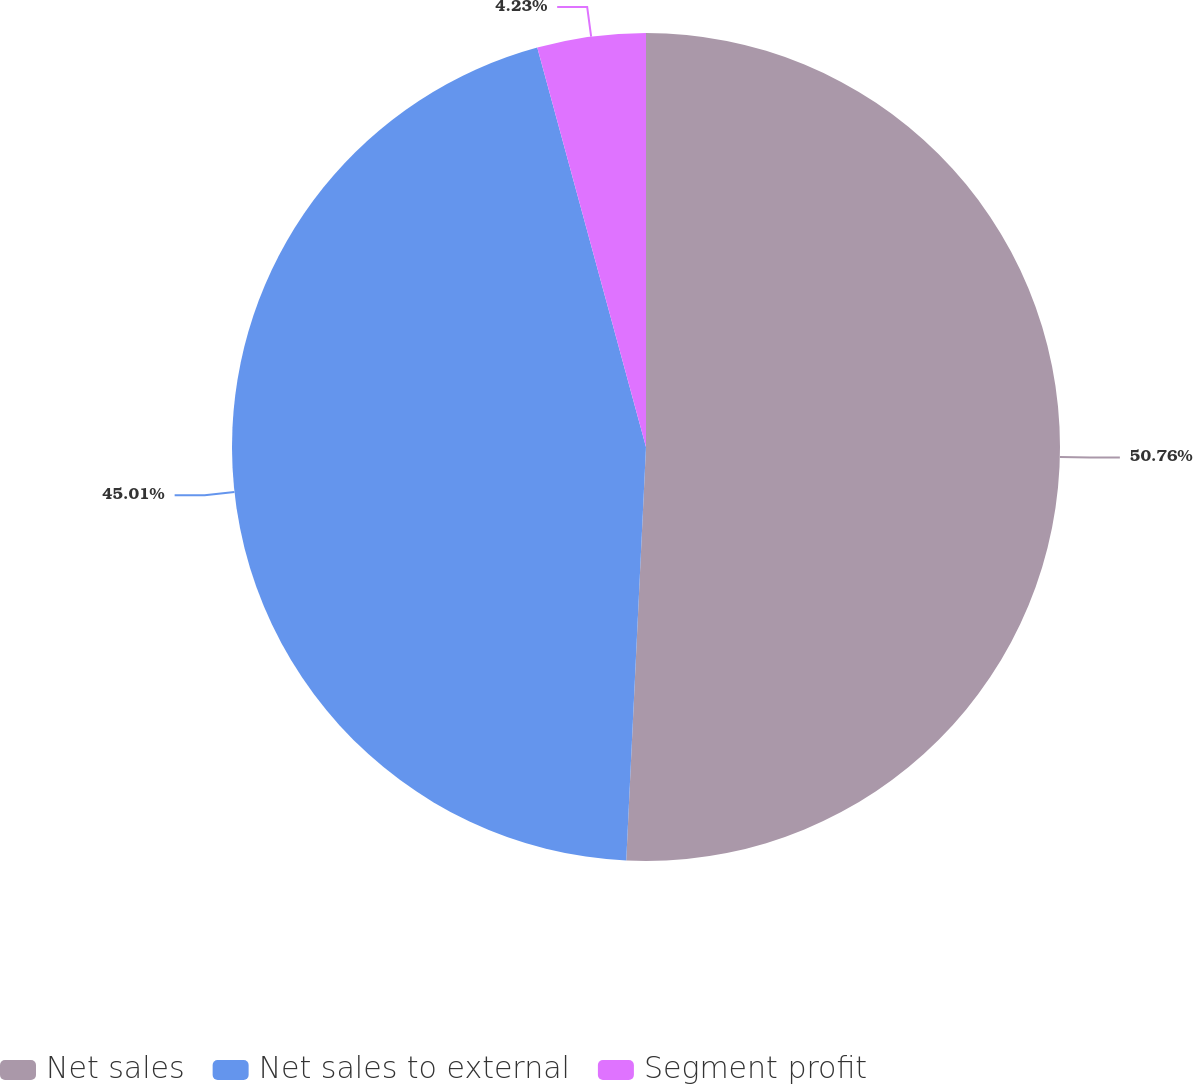Convert chart. <chart><loc_0><loc_0><loc_500><loc_500><pie_chart><fcel>Net sales<fcel>Net sales to external<fcel>Segment profit<nl><fcel>50.76%<fcel>45.01%<fcel>4.23%<nl></chart> 